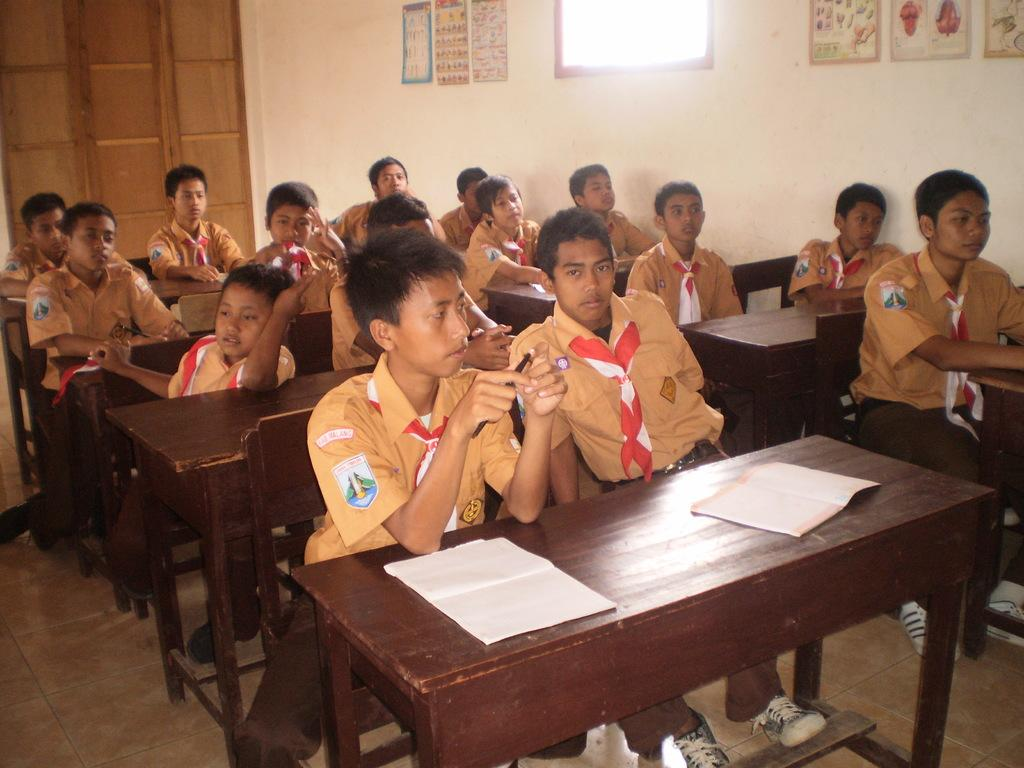What is the main subject of the image? The main subject of the image is a group of people. What are the people doing in the image? The people are sitting on chairs in the image. Can you describe any objects in the image besides the chairs? Yes, there is a book and pictures on the wall in the image. What type of drawer can be seen in the image? There is no drawer present in the image. How does the group of people express disgust in the image? The image does not show any expressions of disgust; the people are simply sitting on chairs. 